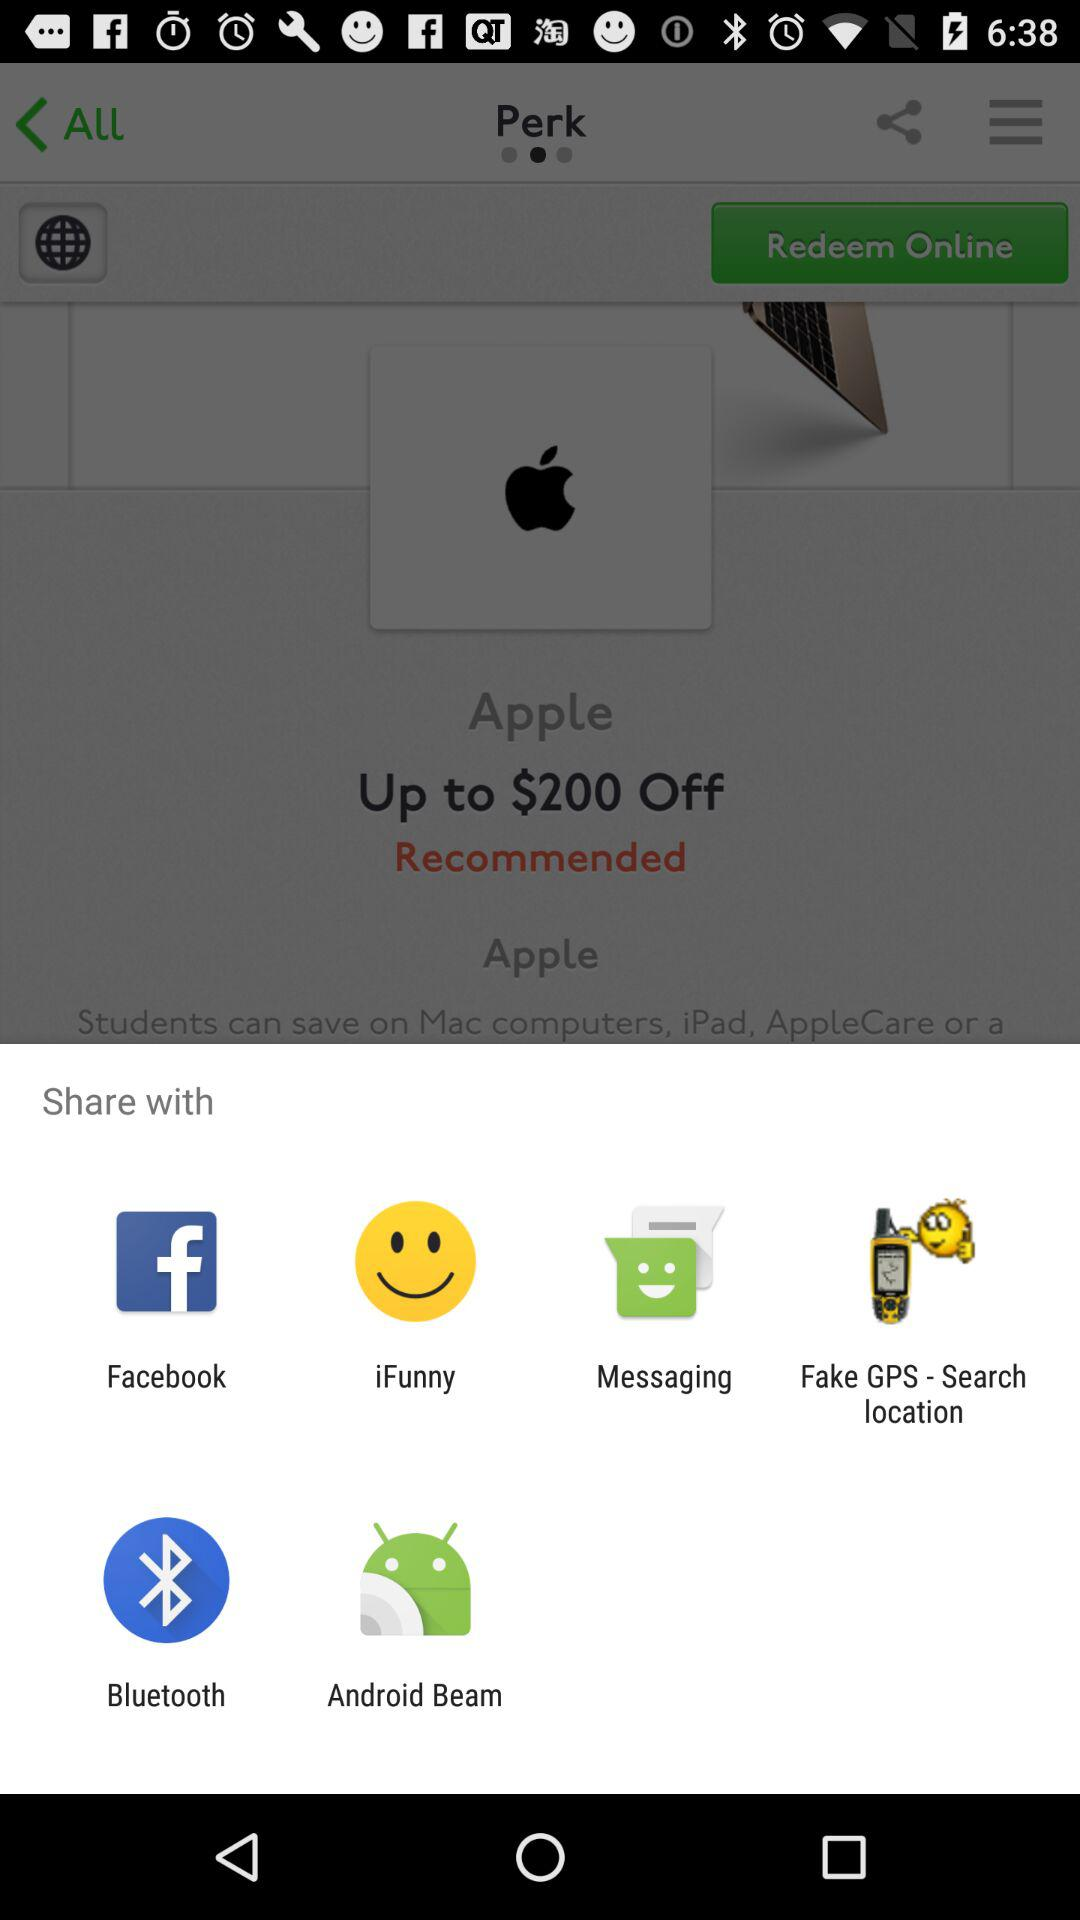What are the sharing options? The sharing options are "Facebook", "iFunny", "Messaging", "Fake GPS - Search location", "Bluetooth", and "Android Beam". 